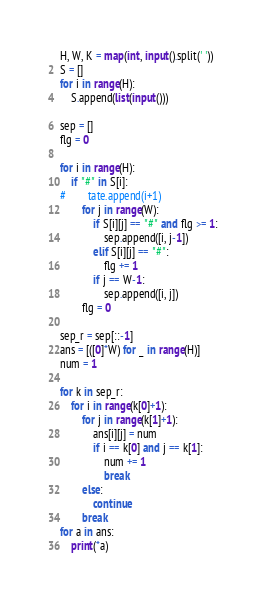Convert code to text. <code><loc_0><loc_0><loc_500><loc_500><_Python_>H, W, K = map(int, input().split(' '))
S = []
for i in range(H):
    S.append(list(input()))

sep = []
flg = 0

for i in range(H):
    if "#" in S[i]:
#        tate.append(i+1)
        for j in range(W):
            if S[i][j] == "#" and flg >= 1:
                sep.append([i, j-1])
            elif S[i][j] == "#":
                flg += 1
            if j == W-1:
                sep.append([i, j])
        flg = 0

sep_r = sep[::-1]
ans = [([0]*W) for _ in range(H)]
num = 1

for k in sep_r:
    for i in range(k[0]+1):
        for j in range(k[1]+1):
            ans[i][j] = num
            if i == k[0] and j == k[1]:
                num += 1
                break
        else:
            continue 
        break
for a in ans:
    print(*a)</code> 